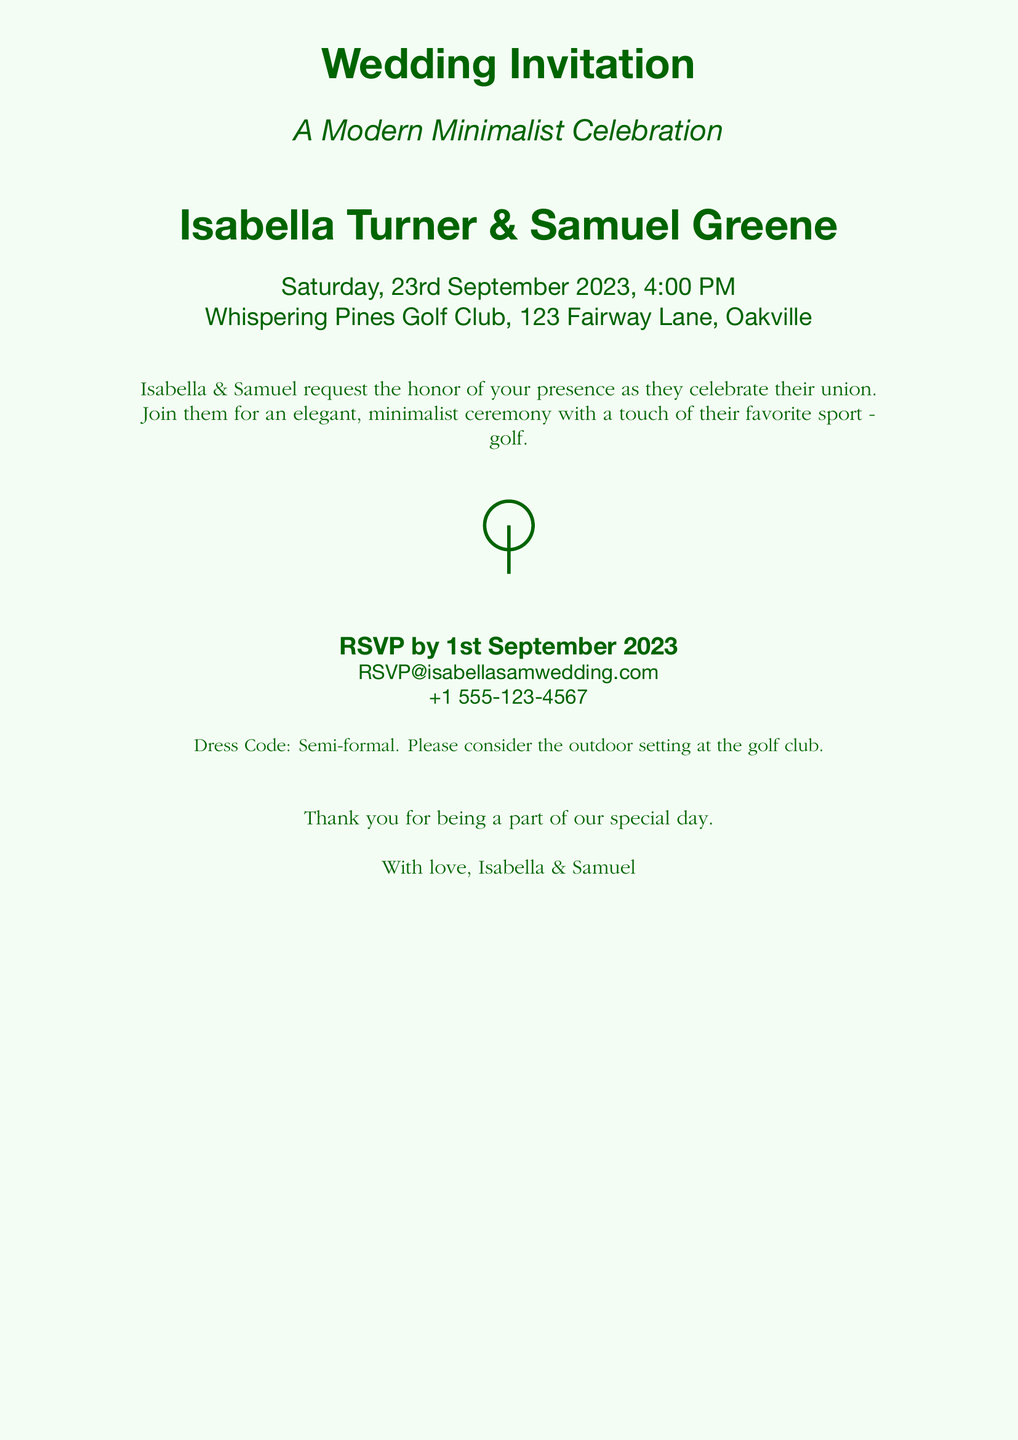What are the names of the couple? The names of the couple are explicitly stated in the invitation as Isabella Turner and Samuel Greene.
Answer: Isabella Turner & Samuel Greene What is the date of the wedding? The date of the wedding is clearly mentioned in the document as Saturday, 23rd September 2023.
Answer: 23rd September 2023 What location is the wedding taking place? The wedding location is specified as Whispering Pines Golf Club, which is included in the address provided.
Answer: Whispering Pines Golf Club What time does the wedding ceremony start? The time of the wedding ceremony is listed in the document as 4:00 PM.
Answer: 4:00 PM What is the RSVP deadline? The RSVP deadline is highlighted as 1st September 2023 in the invitation.
Answer: 1st September 2023 What is the dress code? The dress code for the event is mentioned in the document, indicating a style of clothing expected from guests.
Answer: Semi-formal What sport is referenced in the invitation? The invitation includes a reference to a sport that reflects the couple's interests, which should be easily identifiable.
Answer: Golf What color theme is used in the invitation? The dominant color theme of the invitation is derived from the background and text colors specified, which convey a certain aesthetic.
Answer: Monochrome with light and dark green 